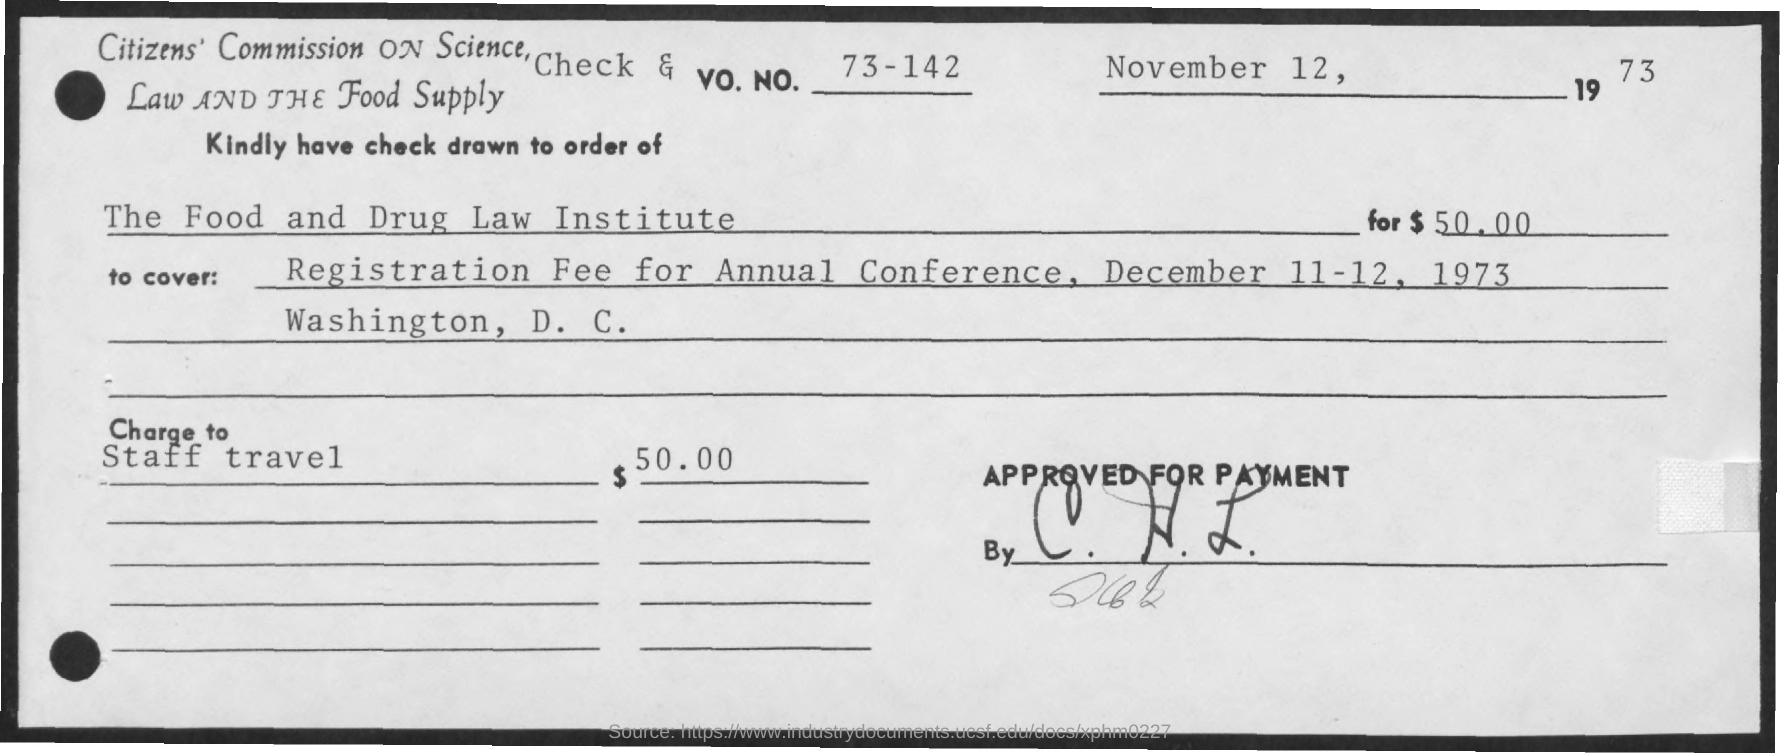Outline some significant characteristics in this image. The check is issued from the Food and Drug Law Institute at [name of institute]. The Vo. No. mentioned in the check is 73-142, 